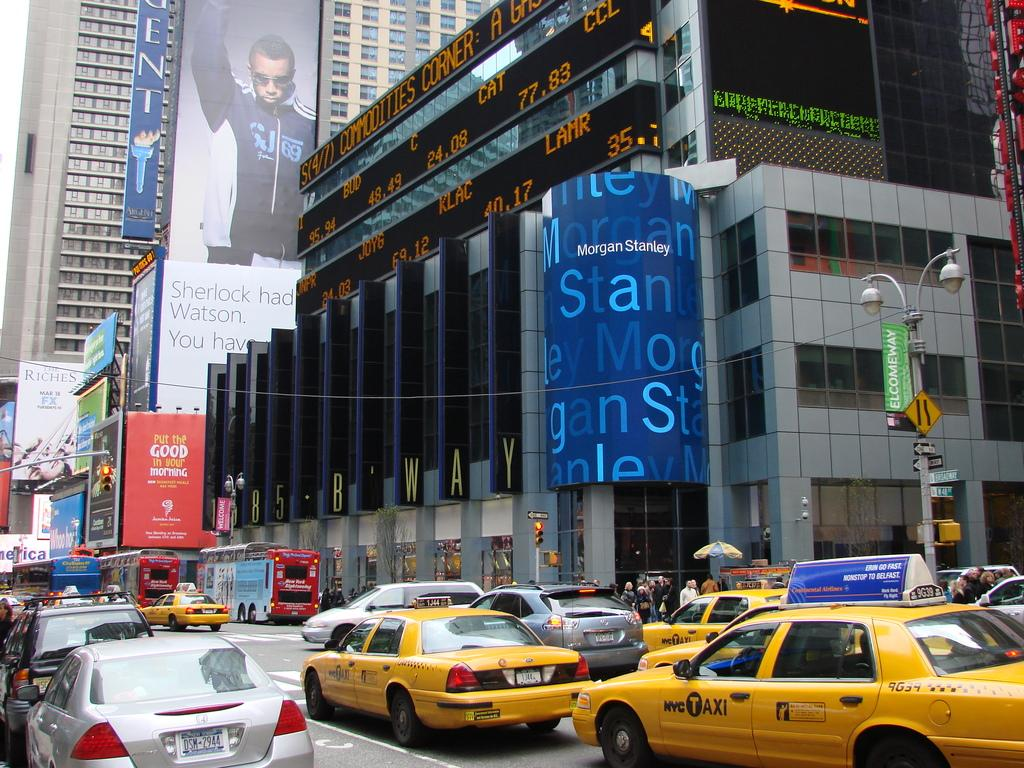<image>
Share a concise interpretation of the image provided. A slew of yellow cabs pass the Morgan Stanley building in New York City. 